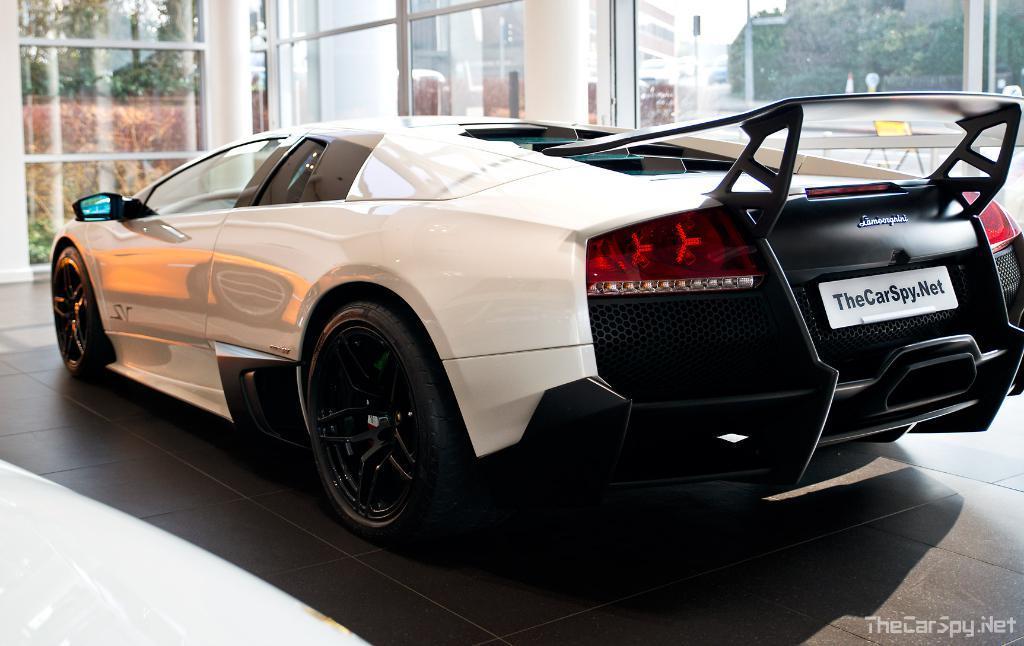Could you give a brief overview of what you see in this image? In this image I can see the car and the car is in white and black color. In the background I can see few glass walls, trees in green color, buildings, poles and the sky is in white color. 